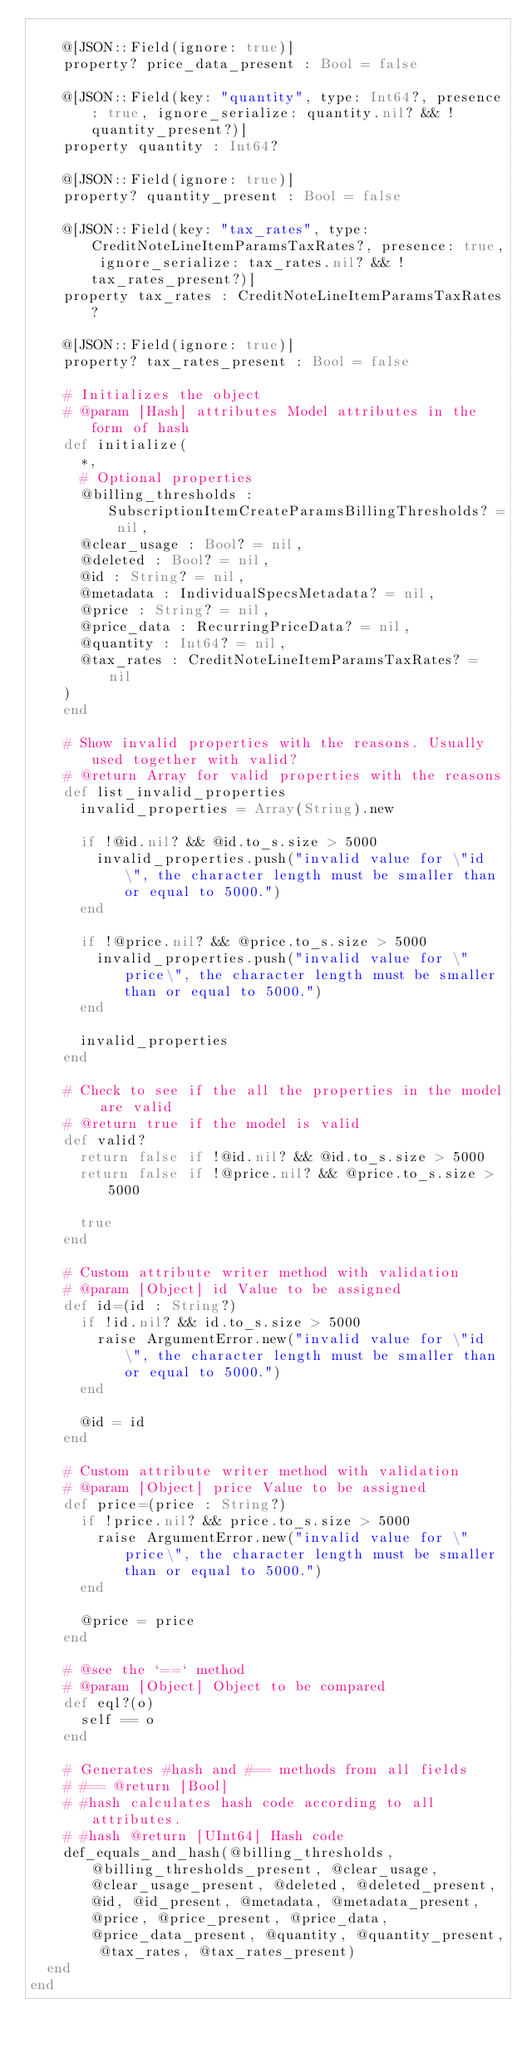Convert code to text. <code><loc_0><loc_0><loc_500><loc_500><_Crystal_>
    @[JSON::Field(ignore: true)]
    property? price_data_present : Bool = false

    @[JSON::Field(key: "quantity", type: Int64?, presence: true, ignore_serialize: quantity.nil? && !quantity_present?)]
    property quantity : Int64?

    @[JSON::Field(ignore: true)]
    property? quantity_present : Bool = false

    @[JSON::Field(key: "tax_rates", type: CreditNoteLineItemParamsTaxRates?, presence: true, ignore_serialize: tax_rates.nil? && !tax_rates_present?)]
    property tax_rates : CreditNoteLineItemParamsTaxRates?

    @[JSON::Field(ignore: true)]
    property? tax_rates_present : Bool = false

    # Initializes the object
    # @param [Hash] attributes Model attributes in the form of hash
    def initialize(
      *,
      # Optional properties
      @billing_thresholds : SubscriptionItemCreateParamsBillingThresholds? = nil,
      @clear_usage : Bool? = nil,
      @deleted : Bool? = nil,
      @id : String? = nil,
      @metadata : IndividualSpecsMetadata? = nil,
      @price : String? = nil,
      @price_data : RecurringPriceData? = nil,
      @quantity : Int64? = nil,
      @tax_rates : CreditNoteLineItemParamsTaxRates? = nil
    )
    end

    # Show invalid properties with the reasons. Usually used together with valid?
    # @return Array for valid properties with the reasons
    def list_invalid_properties
      invalid_properties = Array(String).new

      if !@id.nil? && @id.to_s.size > 5000
        invalid_properties.push("invalid value for \"id\", the character length must be smaller than or equal to 5000.")
      end

      if !@price.nil? && @price.to_s.size > 5000
        invalid_properties.push("invalid value for \"price\", the character length must be smaller than or equal to 5000.")
      end

      invalid_properties
    end

    # Check to see if the all the properties in the model are valid
    # @return true if the model is valid
    def valid?
      return false if !@id.nil? && @id.to_s.size > 5000
      return false if !@price.nil? && @price.to_s.size > 5000

      true
    end

    # Custom attribute writer method with validation
    # @param [Object] id Value to be assigned
    def id=(id : String?)
      if !id.nil? && id.to_s.size > 5000
        raise ArgumentError.new("invalid value for \"id\", the character length must be smaller than or equal to 5000.")
      end

      @id = id
    end

    # Custom attribute writer method with validation
    # @param [Object] price Value to be assigned
    def price=(price : String?)
      if !price.nil? && price.to_s.size > 5000
        raise ArgumentError.new("invalid value for \"price\", the character length must be smaller than or equal to 5000.")
      end

      @price = price
    end

    # @see the `==` method
    # @param [Object] Object to be compared
    def eql?(o)
      self == o
    end

    # Generates #hash and #== methods from all fields
    # #== @return [Bool]
    # #hash calculates hash code according to all attributes.
    # #hash @return [UInt64] Hash code
    def_equals_and_hash(@billing_thresholds, @billing_thresholds_present, @clear_usage, @clear_usage_present, @deleted, @deleted_present, @id, @id_present, @metadata, @metadata_present, @price, @price_present, @price_data, @price_data_present, @quantity, @quantity_present, @tax_rates, @tax_rates_present)
  end
end
</code> 